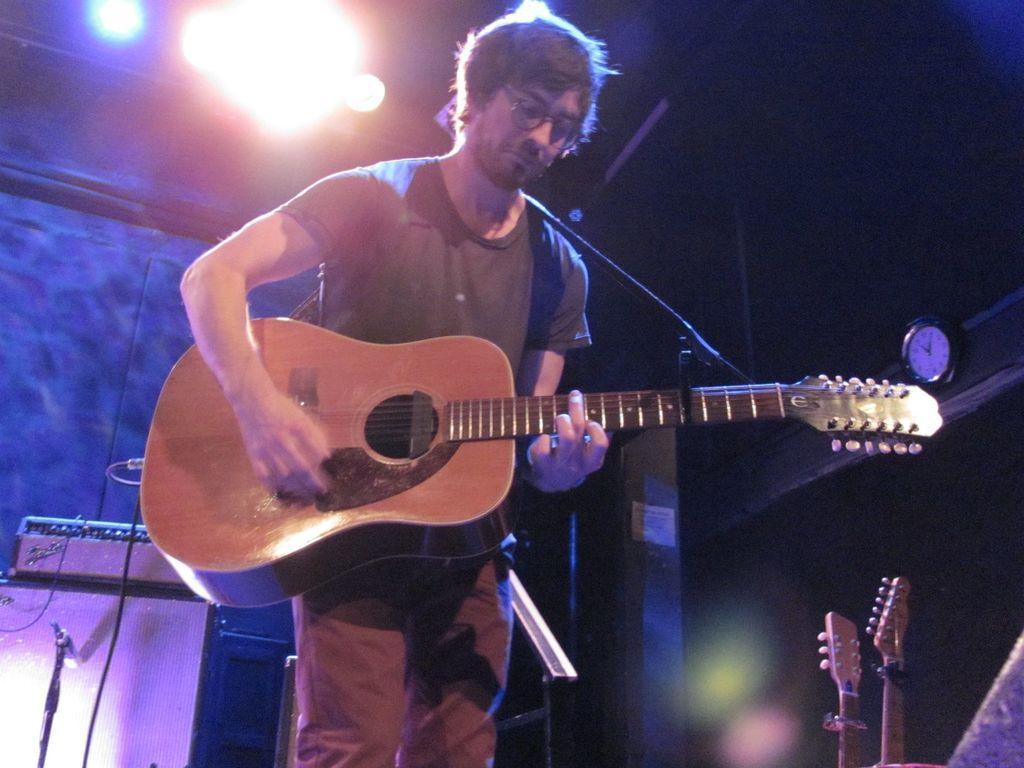How would you summarize this image in a sentence or two? A man is playing guitar behind him there are musical instruments and lights. 